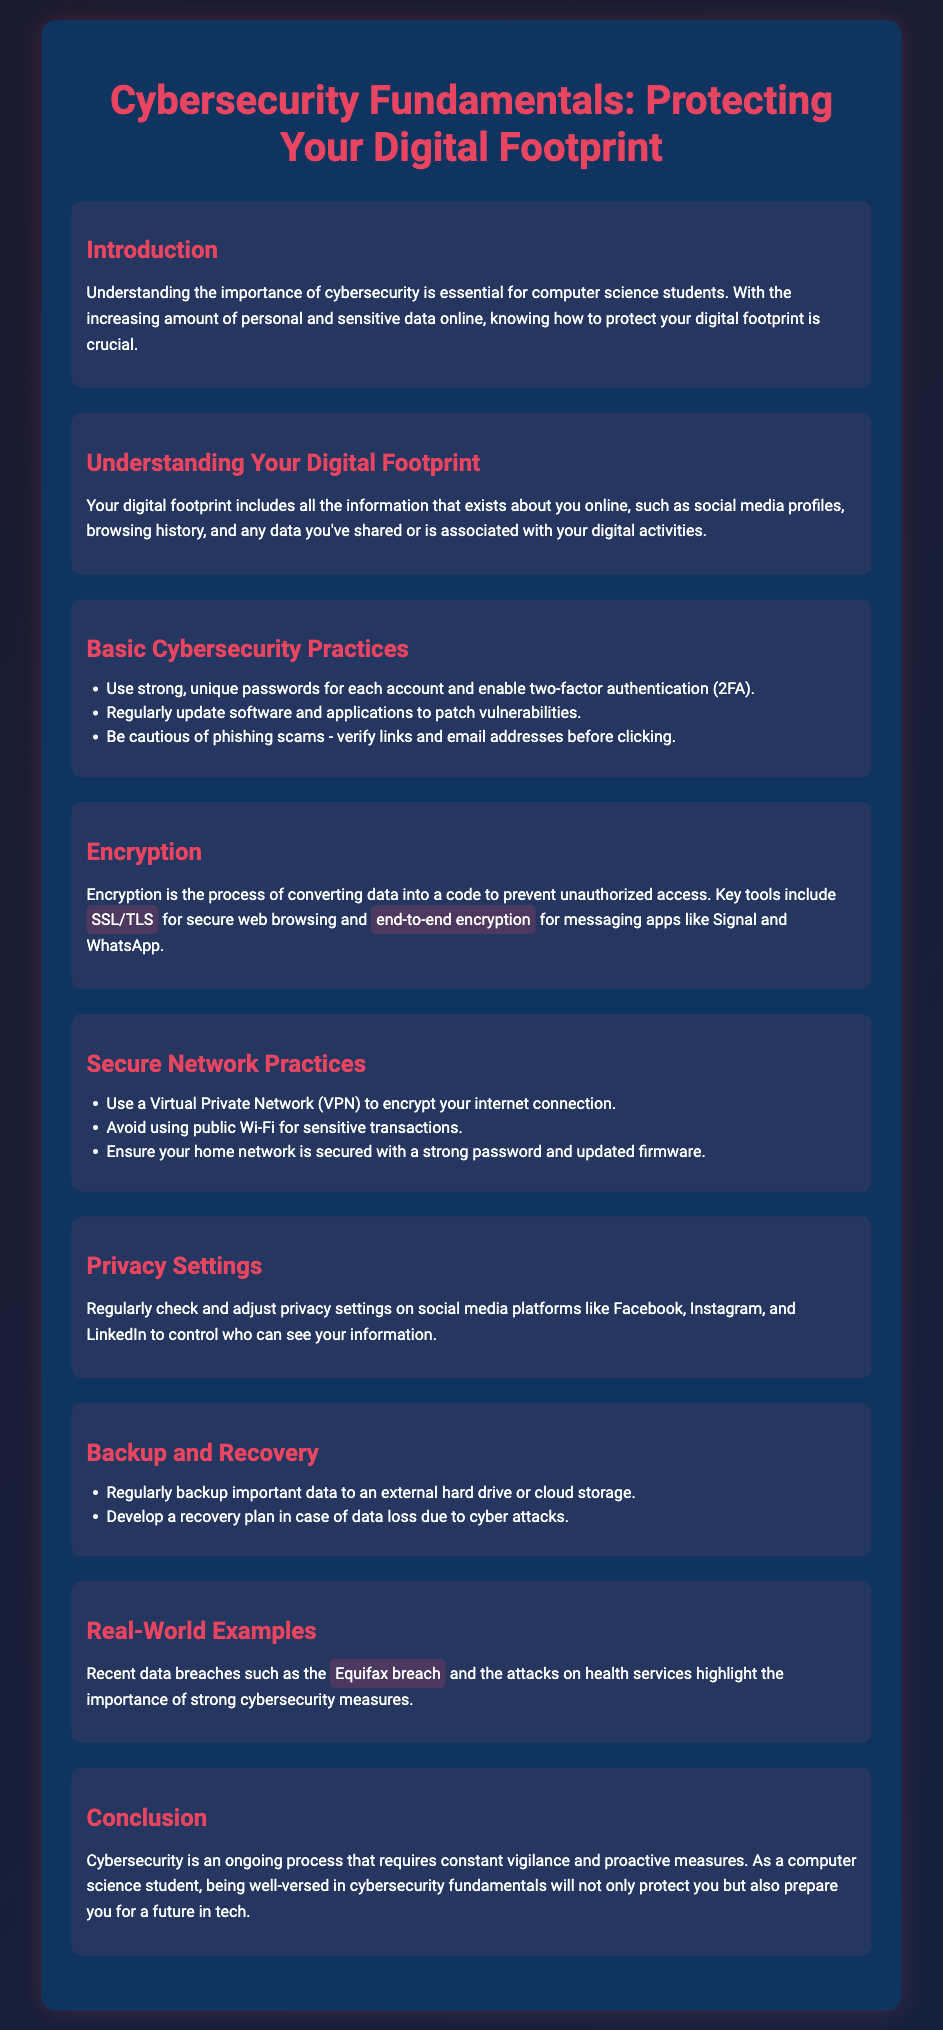what is the title of the presentation? The title of the presentation is found at the top of the document.
Answer: Cybersecurity Fundamentals: Protecting Your Digital Footprint what is included in your digital footprint? The document describes various forms of personal information that can exist online.
Answer: Social media profiles, browsing history, and data shared name one basic cybersecurity practice. The document lists practices that help in protecting against cyber threats.
Answer: Use strong, unique passwords what does encryption do? The explanation of encryption is provided in the section discussing its purpose.
Answer: Prevent unauthorized access what should you use to secure your internet connection? The document suggests tools for safeguarding online activities.
Answer: Virtual Private Network (VPN) name one of the recent data breaches mentioned. The document provides examples of significant data breaches to illustrate its points.
Answer: Equifax breach how often should you back up important data? The document emphasizes regularity in backing up data to secure it against loss.
Answer: Regularly what is a recommended practice for social media privacy settings? The document advises checking privacy settings on social media platforms.
Answer: Regularly check and adjust privacy settings what is the main focus of the conclusion section? The conclusion summarizes the content and its importance for a specific audience.
Answer: Ongoing process requiring constant vigilance 